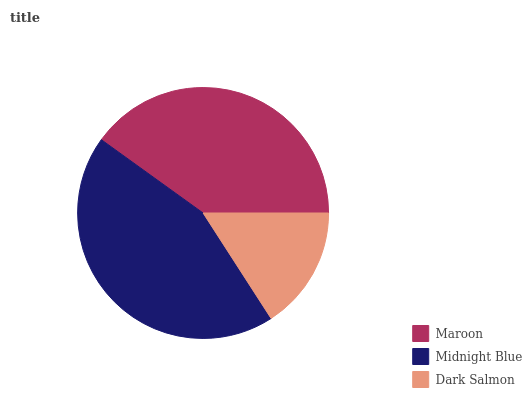Is Dark Salmon the minimum?
Answer yes or no. Yes. Is Midnight Blue the maximum?
Answer yes or no. Yes. Is Midnight Blue the minimum?
Answer yes or no. No. Is Dark Salmon the maximum?
Answer yes or no. No. Is Midnight Blue greater than Dark Salmon?
Answer yes or no. Yes. Is Dark Salmon less than Midnight Blue?
Answer yes or no. Yes. Is Dark Salmon greater than Midnight Blue?
Answer yes or no. No. Is Midnight Blue less than Dark Salmon?
Answer yes or no. No. Is Maroon the high median?
Answer yes or no. Yes. Is Maroon the low median?
Answer yes or no. Yes. Is Midnight Blue the high median?
Answer yes or no. No. Is Midnight Blue the low median?
Answer yes or no. No. 